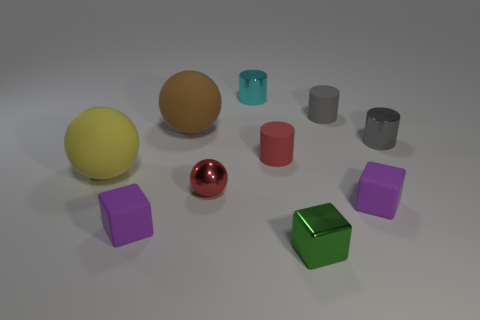Subtract all purple rubber blocks. How many blocks are left? 1 Subtract all yellow spheres. How many spheres are left? 2 Subtract all balls. How many objects are left? 7 Add 1 tiny red cylinders. How many tiny red cylinders are left? 2 Add 1 tiny blue metal blocks. How many tiny blue metal blocks exist? 1 Subtract 0 purple spheres. How many objects are left? 10 Subtract 3 blocks. How many blocks are left? 0 Subtract all green cubes. Subtract all cyan balls. How many cubes are left? 2 Subtract all brown balls. How many brown cylinders are left? 0 Subtract all red cylinders. Subtract all small rubber things. How many objects are left? 5 